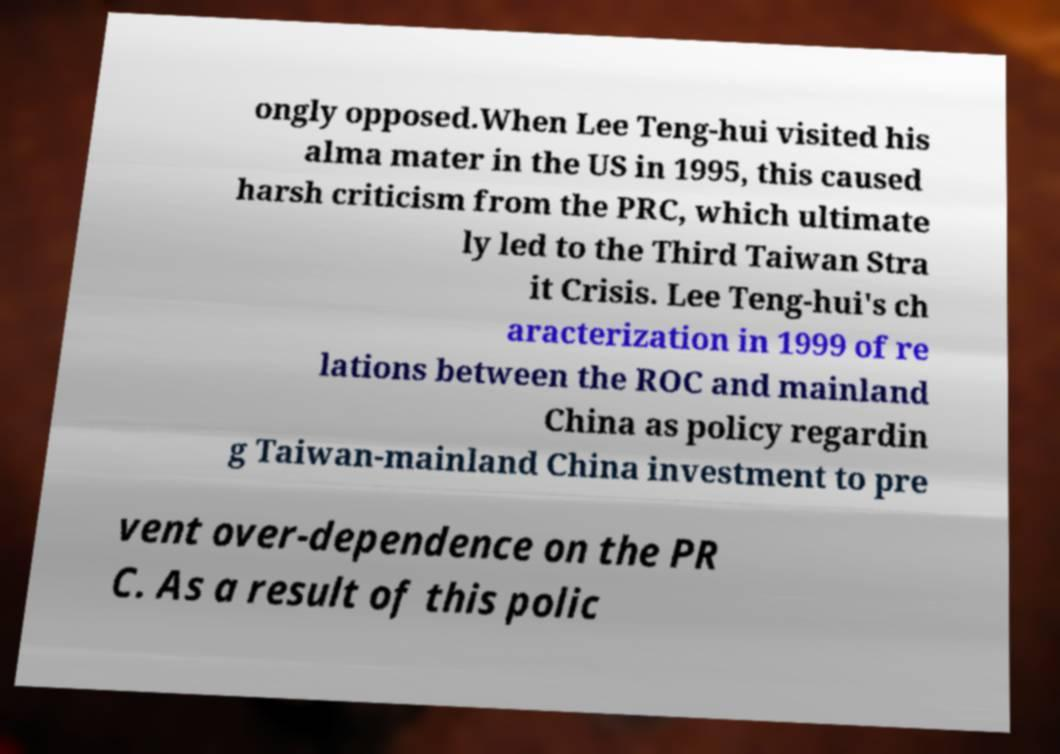Can you read and provide the text displayed in the image?This photo seems to have some interesting text. Can you extract and type it out for me? ongly opposed.When Lee Teng-hui visited his alma mater in the US in 1995, this caused harsh criticism from the PRC, which ultimate ly led to the Third Taiwan Stra it Crisis. Lee Teng-hui's ch aracterization in 1999 of re lations between the ROC and mainland China as policy regardin g Taiwan-mainland China investment to pre vent over-dependence on the PR C. As a result of this polic 